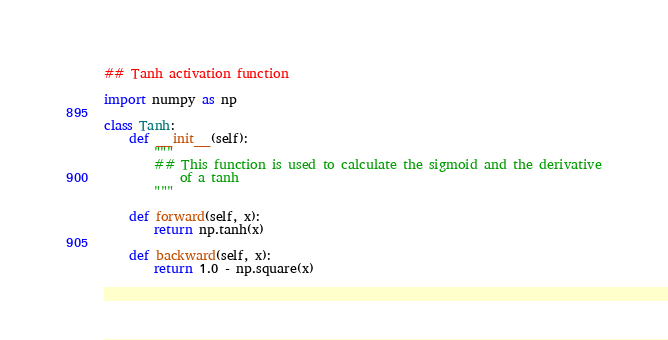<code> <loc_0><loc_0><loc_500><loc_500><_Python_>## Tanh activation function

import numpy as np

class Tanh:
    def __init__(self):
        """
        ## This function is used to calculate the sigmoid and the derivative
            of a tanh
        """

    def forward(self, x):
        return np.tanh(x)

    def backward(self, x):
        return 1.0 - np.square(x)
</code> 